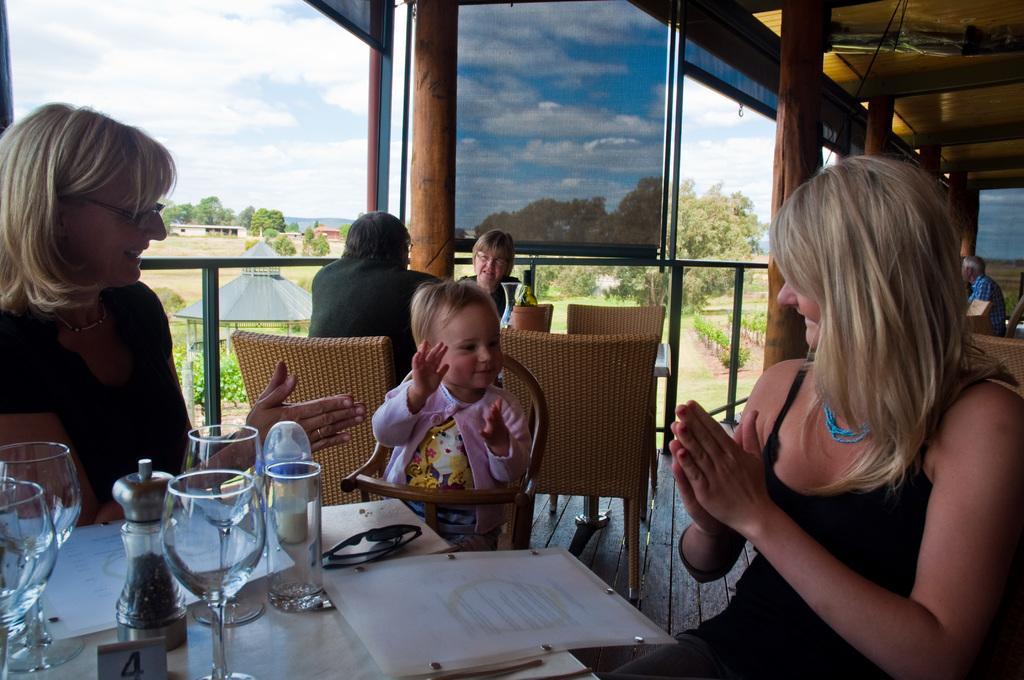How would you summarize this image in a sentence or two? in this picture there are two persons sitting beside a baby there is a table in front of them ,on the table we can see,glasses menu and everything,we can also see two persons sitting bit away from them,we can see a clear sky,trees. 